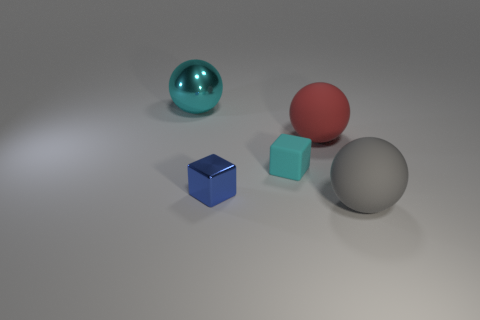Subtract all green cubes. Subtract all blue spheres. How many cubes are left? 2 Add 3 large blue objects. How many objects exist? 8 Subtract all spheres. How many objects are left? 2 Subtract all large gray rubber things. Subtract all red balls. How many objects are left? 3 Add 1 gray balls. How many gray balls are left? 2 Add 1 gray spheres. How many gray spheres exist? 2 Subtract 0 red cylinders. How many objects are left? 5 